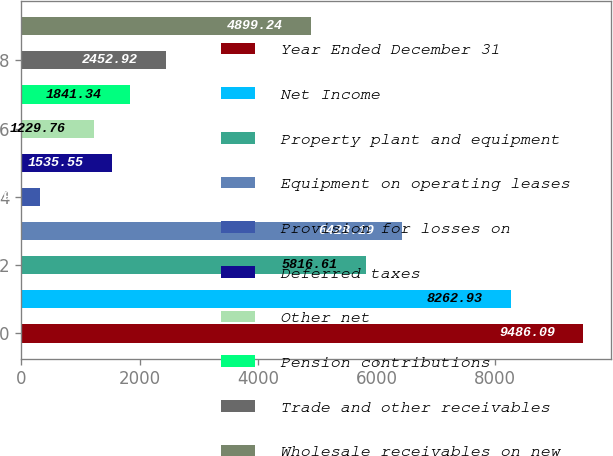Convert chart. <chart><loc_0><loc_0><loc_500><loc_500><bar_chart><fcel>Year Ended December 31<fcel>Net Income<fcel>Property plant and equipment<fcel>Equipment on operating leases<fcel>Provision for losses on<fcel>Deferred taxes<fcel>Other net<fcel>Pension contributions<fcel>Trade and other receivables<fcel>Wholesale receivables on new<nl><fcel>9486.09<fcel>8262.93<fcel>5816.61<fcel>6428.19<fcel>312.39<fcel>1535.55<fcel>1229.76<fcel>1841.34<fcel>2452.92<fcel>4899.24<nl></chart> 